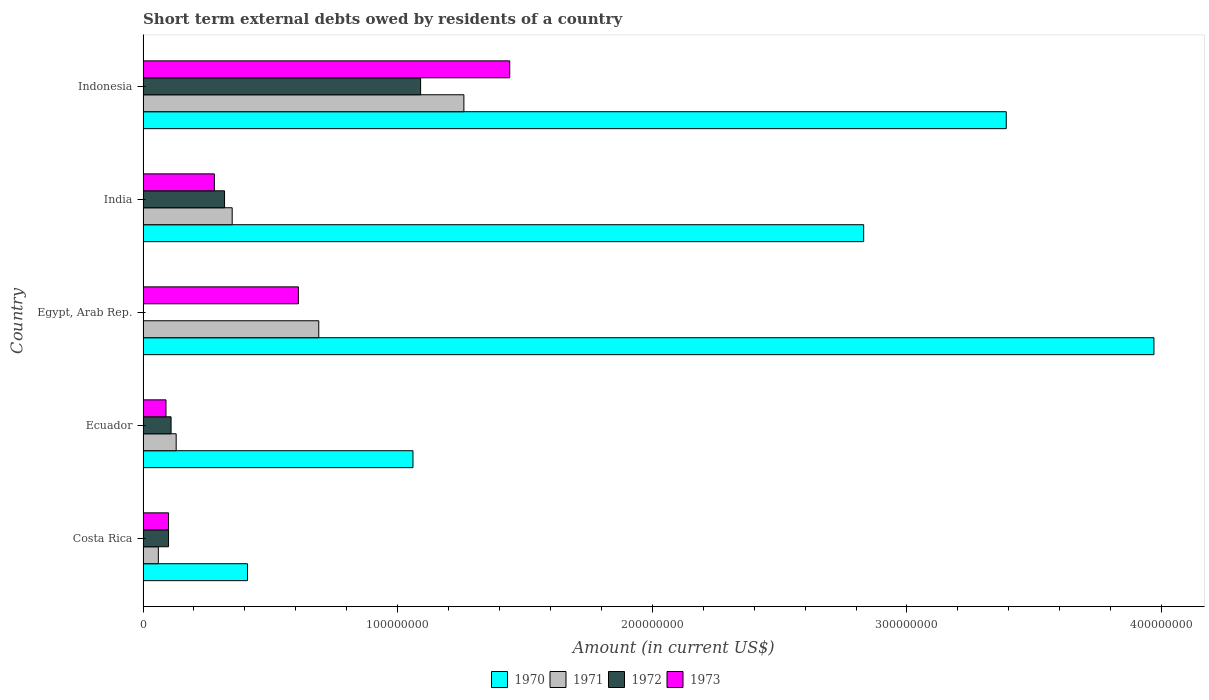How many different coloured bars are there?
Ensure brevity in your answer.  4. How many groups of bars are there?
Your answer should be compact. 5. Are the number of bars per tick equal to the number of legend labels?
Your response must be concise. No. Are the number of bars on each tick of the Y-axis equal?
Your answer should be compact. No. How many bars are there on the 2nd tick from the top?
Make the answer very short. 4. How many bars are there on the 3rd tick from the bottom?
Your response must be concise. 3. What is the label of the 5th group of bars from the top?
Provide a short and direct response. Costa Rica. In how many cases, is the number of bars for a given country not equal to the number of legend labels?
Provide a short and direct response. 1. What is the amount of short-term external debts owed by residents in 1973 in Egypt, Arab Rep.?
Give a very brief answer. 6.10e+07. Across all countries, what is the maximum amount of short-term external debts owed by residents in 1970?
Give a very brief answer. 3.97e+08. Across all countries, what is the minimum amount of short-term external debts owed by residents in 1973?
Provide a succinct answer. 9.00e+06. In which country was the amount of short-term external debts owed by residents in 1972 maximum?
Give a very brief answer. Indonesia. What is the total amount of short-term external debts owed by residents in 1973 in the graph?
Keep it short and to the point. 2.52e+08. What is the difference between the amount of short-term external debts owed by residents in 1973 in Ecuador and that in Egypt, Arab Rep.?
Offer a terse response. -5.20e+07. What is the difference between the amount of short-term external debts owed by residents in 1973 in Egypt, Arab Rep. and the amount of short-term external debts owed by residents in 1970 in India?
Ensure brevity in your answer.  -2.22e+08. What is the average amount of short-term external debts owed by residents in 1970 per country?
Offer a terse response. 2.33e+08. What is the ratio of the amount of short-term external debts owed by residents in 1973 in Costa Rica to that in Ecuador?
Provide a succinct answer. 1.11. Is the difference between the amount of short-term external debts owed by residents in 1972 in Costa Rica and Ecuador greater than the difference between the amount of short-term external debts owed by residents in 1971 in Costa Rica and Ecuador?
Make the answer very short. Yes. What is the difference between the highest and the second highest amount of short-term external debts owed by residents in 1973?
Keep it short and to the point. 8.30e+07. What is the difference between the highest and the lowest amount of short-term external debts owed by residents in 1971?
Ensure brevity in your answer.  1.20e+08. How many bars are there?
Offer a terse response. 19. Does the graph contain grids?
Your answer should be compact. No. Where does the legend appear in the graph?
Your answer should be compact. Bottom center. How many legend labels are there?
Your response must be concise. 4. What is the title of the graph?
Provide a short and direct response. Short term external debts owed by residents of a country. What is the label or title of the X-axis?
Offer a very short reply. Amount (in current US$). What is the label or title of the Y-axis?
Your answer should be very brief. Country. What is the Amount (in current US$) in 1970 in Costa Rica?
Ensure brevity in your answer.  4.10e+07. What is the Amount (in current US$) in 1973 in Costa Rica?
Your response must be concise. 1.00e+07. What is the Amount (in current US$) of 1970 in Ecuador?
Ensure brevity in your answer.  1.06e+08. What is the Amount (in current US$) of 1971 in Ecuador?
Offer a terse response. 1.30e+07. What is the Amount (in current US$) in 1972 in Ecuador?
Keep it short and to the point. 1.10e+07. What is the Amount (in current US$) of 1973 in Ecuador?
Provide a succinct answer. 9.00e+06. What is the Amount (in current US$) in 1970 in Egypt, Arab Rep.?
Offer a terse response. 3.97e+08. What is the Amount (in current US$) of 1971 in Egypt, Arab Rep.?
Your answer should be very brief. 6.90e+07. What is the Amount (in current US$) of 1973 in Egypt, Arab Rep.?
Offer a very short reply. 6.10e+07. What is the Amount (in current US$) of 1970 in India?
Your answer should be very brief. 2.83e+08. What is the Amount (in current US$) in 1971 in India?
Your answer should be very brief. 3.50e+07. What is the Amount (in current US$) of 1972 in India?
Offer a very short reply. 3.20e+07. What is the Amount (in current US$) in 1973 in India?
Provide a short and direct response. 2.80e+07. What is the Amount (in current US$) in 1970 in Indonesia?
Your answer should be compact. 3.39e+08. What is the Amount (in current US$) in 1971 in Indonesia?
Your response must be concise. 1.26e+08. What is the Amount (in current US$) of 1972 in Indonesia?
Provide a short and direct response. 1.09e+08. What is the Amount (in current US$) of 1973 in Indonesia?
Give a very brief answer. 1.44e+08. Across all countries, what is the maximum Amount (in current US$) of 1970?
Your response must be concise. 3.97e+08. Across all countries, what is the maximum Amount (in current US$) of 1971?
Make the answer very short. 1.26e+08. Across all countries, what is the maximum Amount (in current US$) of 1972?
Keep it short and to the point. 1.09e+08. Across all countries, what is the maximum Amount (in current US$) of 1973?
Your response must be concise. 1.44e+08. Across all countries, what is the minimum Amount (in current US$) in 1970?
Your answer should be very brief. 4.10e+07. Across all countries, what is the minimum Amount (in current US$) of 1973?
Keep it short and to the point. 9.00e+06. What is the total Amount (in current US$) of 1970 in the graph?
Your response must be concise. 1.17e+09. What is the total Amount (in current US$) of 1971 in the graph?
Your answer should be compact. 2.49e+08. What is the total Amount (in current US$) of 1972 in the graph?
Keep it short and to the point. 1.62e+08. What is the total Amount (in current US$) of 1973 in the graph?
Ensure brevity in your answer.  2.52e+08. What is the difference between the Amount (in current US$) in 1970 in Costa Rica and that in Ecuador?
Your response must be concise. -6.50e+07. What is the difference between the Amount (in current US$) of 1971 in Costa Rica and that in Ecuador?
Make the answer very short. -7.00e+06. What is the difference between the Amount (in current US$) in 1970 in Costa Rica and that in Egypt, Arab Rep.?
Keep it short and to the point. -3.56e+08. What is the difference between the Amount (in current US$) in 1971 in Costa Rica and that in Egypt, Arab Rep.?
Offer a very short reply. -6.30e+07. What is the difference between the Amount (in current US$) of 1973 in Costa Rica and that in Egypt, Arab Rep.?
Give a very brief answer. -5.10e+07. What is the difference between the Amount (in current US$) of 1970 in Costa Rica and that in India?
Ensure brevity in your answer.  -2.42e+08. What is the difference between the Amount (in current US$) of 1971 in Costa Rica and that in India?
Offer a terse response. -2.90e+07. What is the difference between the Amount (in current US$) in 1972 in Costa Rica and that in India?
Provide a short and direct response. -2.20e+07. What is the difference between the Amount (in current US$) of 1973 in Costa Rica and that in India?
Ensure brevity in your answer.  -1.80e+07. What is the difference between the Amount (in current US$) in 1970 in Costa Rica and that in Indonesia?
Offer a very short reply. -2.98e+08. What is the difference between the Amount (in current US$) of 1971 in Costa Rica and that in Indonesia?
Provide a succinct answer. -1.20e+08. What is the difference between the Amount (in current US$) of 1972 in Costa Rica and that in Indonesia?
Provide a short and direct response. -9.90e+07. What is the difference between the Amount (in current US$) of 1973 in Costa Rica and that in Indonesia?
Your answer should be very brief. -1.34e+08. What is the difference between the Amount (in current US$) in 1970 in Ecuador and that in Egypt, Arab Rep.?
Provide a succinct answer. -2.91e+08. What is the difference between the Amount (in current US$) of 1971 in Ecuador and that in Egypt, Arab Rep.?
Provide a short and direct response. -5.60e+07. What is the difference between the Amount (in current US$) in 1973 in Ecuador and that in Egypt, Arab Rep.?
Your response must be concise. -5.20e+07. What is the difference between the Amount (in current US$) of 1970 in Ecuador and that in India?
Provide a succinct answer. -1.77e+08. What is the difference between the Amount (in current US$) in 1971 in Ecuador and that in India?
Provide a succinct answer. -2.20e+07. What is the difference between the Amount (in current US$) in 1972 in Ecuador and that in India?
Provide a short and direct response. -2.10e+07. What is the difference between the Amount (in current US$) of 1973 in Ecuador and that in India?
Provide a succinct answer. -1.90e+07. What is the difference between the Amount (in current US$) of 1970 in Ecuador and that in Indonesia?
Keep it short and to the point. -2.33e+08. What is the difference between the Amount (in current US$) in 1971 in Ecuador and that in Indonesia?
Your answer should be very brief. -1.13e+08. What is the difference between the Amount (in current US$) of 1972 in Ecuador and that in Indonesia?
Offer a terse response. -9.80e+07. What is the difference between the Amount (in current US$) in 1973 in Ecuador and that in Indonesia?
Ensure brevity in your answer.  -1.35e+08. What is the difference between the Amount (in current US$) of 1970 in Egypt, Arab Rep. and that in India?
Ensure brevity in your answer.  1.14e+08. What is the difference between the Amount (in current US$) in 1971 in Egypt, Arab Rep. and that in India?
Make the answer very short. 3.40e+07. What is the difference between the Amount (in current US$) of 1973 in Egypt, Arab Rep. and that in India?
Your answer should be very brief. 3.30e+07. What is the difference between the Amount (in current US$) of 1970 in Egypt, Arab Rep. and that in Indonesia?
Your response must be concise. 5.80e+07. What is the difference between the Amount (in current US$) in 1971 in Egypt, Arab Rep. and that in Indonesia?
Your answer should be compact. -5.70e+07. What is the difference between the Amount (in current US$) in 1973 in Egypt, Arab Rep. and that in Indonesia?
Make the answer very short. -8.30e+07. What is the difference between the Amount (in current US$) in 1970 in India and that in Indonesia?
Your answer should be very brief. -5.60e+07. What is the difference between the Amount (in current US$) in 1971 in India and that in Indonesia?
Ensure brevity in your answer.  -9.10e+07. What is the difference between the Amount (in current US$) in 1972 in India and that in Indonesia?
Offer a terse response. -7.70e+07. What is the difference between the Amount (in current US$) in 1973 in India and that in Indonesia?
Provide a succinct answer. -1.16e+08. What is the difference between the Amount (in current US$) in 1970 in Costa Rica and the Amount (in current US$) in 1971 in Ecuador?
Keep it short and to the point. 2.80e+07. What is the difference between the Amount (in current US$) of 1970 in Costa Rica and the Amount (in current US$) of 1972 in Ecuador?
Your answer should be very brief. 3.00e+07. What is the difference between the Amount (in current US$) of 1970 in Costa Rica and the Amount (in current US$) of 1973 in Ecuador?
Your answer should be very brief. 3.20e+07. What is the difference between the Amount (in current US$) of 1971 in Costa Rica and the Amount (in current US$) of 1972 in Ecuador?
Your answer should be very brief. -5.00e+06. What is the difference between the Amount (in current US$) in 1970 in Costa Rica and the Amount (in current US$) in 1971 in Egypt, Arab Rep.?
Your response must be concise. -2.80e+07. What is the difference between the Amount (in current US$) of 1970 in Costa Rica and the Amount (in current US$) of 1973 in Egypt, Arab Rep.?
Keep it short and to the point. -2.00e+07. What is the difference between the Amount (in current US$) in 1971 in Costa Rica and the Amount (in current US$) in 1973 in Egypt, Arab Rep.?
Offer a very short reply. -5.50e+07. What is the difference between the Amount (in current US$) of 1972 in Costa Rica and the Amount (in current US$) of 1973 in Egypt, Arab Rep.?
Offer a very short reply. -5.10e+07. What is the difference between the Amount (in current US$) of 1970 in Costa Rica and the Amount (in current US$) of 1971 in India?
Your answer should be compact. 6.00e+06. What is the difference between the Amount (in current US$) in 1970 in Costa Rica and the Amount (in current US$) in 1972 in India?
Give a very brief answer. 9.00e+06. What is the difference between the Amount (in current US$) in 1970 in Costa Rica and the Amount (in current US$) in 1973 in India?
Make the answer very short. 1.30e+07. What is the difference between the Amount (in current US$) in 1971 in Costa Rica and the Amount (in current US$) in 1972 in India?
Your answer should be very brief. -2.60e+07. What is the difference between the Amount (in current US$) in 1971 in Costa Rica and the Amount (in current US$) in 1973 in India?
Offer a very short reply. -2.20e+07. What is the difference between the Amount (in current US$) of 1972 in Costa Rica and the Amount (in current US$) of 1973 in India?
Provide a short and direct response. -1.80e+07. What is the difference between the Amount (in current US$) in 1970 in Costa Rica and the Amount (in current US$) in 1971 in Indonesia?
Ensure brevity in your answer.  -8.50e+07. What is the difference between the Amount (in current US$) in 1970 in Costa Rica and the Amount (in current US$) in 1972 in Indonesia?
Make the answer very short. -6.80e+07. What is the difference between the Amount (in current US$) in 1970 in Costa Rica and the Amount (in current US$) in 1973 in Indonesia?
Provide a succinct answer. -1.03e+08. What is the difference between the Amount (in current US$) of 1971 in Costa Rica and the Amount (in current US$) of 1972 in Indonesia?
Your answer should be very brief. -1.03e+08. What is the difference between the Amount (in current US$) in 1971 in Costa Rica and the Amount (in current US$) in 1973 in Indonesia?
Your answer should be compact. -1.38e+08. What is the difference between the Amount (in current US$) of 1972 in Costa Rica and the Amount (in current US$) of 1973 in Indonesia?
Make the answer very short. -1.34e+08. What is the difference between the Amount (in current US$) of 1970 in Ecuador and the Amount (in current US$) of 1971 in Egypt, Arab Rep.?
Your answer should be very brief. 3.70e+07. What is the difference between the Amount (in current US$) in 1970 in Ecuador and the Amount (in current US$) in 1973 in Egypt, Arab Rep.?
Ensure brevity in your answer.  4.50e+07. What is the difference between the Amount (in current US$) in 1971 in Ecuador and the Amount (in current US$) in 1973 in Egypt, Arab Rep.?
Ensure brevity in your answer.  -4.80e+07. What is the difference between the Amount (in current US$) in 1972 in Ecuador and the Amount (in current US$) in 1973 in Egypt, Arab Rep.?
Make the answer very short. -5.00e+07. What is the difference between the Amount (in current US$) in 1970 in Ecuador and the Amount (in current US$) in 1971 in India?
Ensure brevity in your answer.  7.10e+07. What is the difference between the Amount (in current US$) in 1970 in Ecuador and the Amount (in current US$) in 1972 in India?
Your answer should be compact. 7.40e+07. What is the difference between the Amount (in current US$) in 1970 in Ecuador and the Amount (in current US$) in 1973 in India?
Keep it short and to the point. 7.80e+07. What is the difference between the Amount (in current US$) of 1971 in Ecuador and the Amount (in current US$) of 1972 in India?
Offer a very short reply. -1.90e+07. What is the difference between the Amount (in current US$) in 1971 in Ecuador and the Amount (in current US$) in 1973 in India?
Ensure brevity in your answer.  -1.50e+07. What is the difference between the Amount (in current US$) in 1972 in Ecuador and the Amount (in current US$) in 1973 in India?
Offer a terse response. -1.70e+07. What is the difference between the Amount (in current US$) of 1970 in Ecuador and the Amount (in current US$) of 1971 in Indonesia?
Your answer should be compact. -2.00e+07. What is the difference between the Amount (in current US$) in 1970 in Ecuador and the Amount (in current US$) in 1973 in Indonesia?
Ensure brevity in your answer.  -3.80e+07. What is the difference between the Amount (in current US$) of 1971 in Ecuador and the Amount (in current US$) of 1972 in Indonesia?
Provide a succinct answer. -9.60e+07. What is the difference between the Amount (in current US$) of 1971 in Ecuador and the Amount (in current US$) of 1973 in Indonesia?
Your response must be concise. -1.31e+08. What is the difference between the Amount (in current US$) of 1972 in Ecuador and the Amount (in current US$) of 1973 in Indonesia?
Give a very brief answer. -1.33e+08. What is the difference between the Amount (in current US$) of 1970 in Egypt, Arab Rep. and the Amount (in current US$) of 1971 in India?
Ensure brevity in your answer.  3.62e+08. What is the difference between the Amount (in current US$) of 1970 in Egypt, Arab Rep. and the Amount (in current US$) of 1972 in India?
Offer a very short reply. 3.65e+08. What is the difference between the Amount (in current US$) in 1970 in Egypt, Arab Rep. and the Amount (in current US$) in 1973 in India?
Offer a very short reply. 3.69e+08. What is the difference between the Amount (in current US$) in 1971 in Egypt, Arab Rep. and the Amount (in current US$) in 1972 in India?
Your response must be concise. 3.70e+07. What is the difference between the Amount (in current US$) of 1971 in Egypt, Arab Rep. and the Amount (in current US$) of 1973 in India?
Provide a succinct answer. 4.10e+07. What is the difference between the Amount (in current US$) in 1970 in Egypt, Arab Rep. and the Amount (in current US$) in 1971 in Indonesia?
Offer a very short reply. 2.71e+08. What is the difference between the Amount (in current US$) of 1970 in Egypt, Arab Rep. and the Amount (in current US$) of 1972 in Indonesia?
Ensure brevity in your answer.  2.88e+08. What is the difference between the Amount (in current US$) of 1970 in Egypt, Arab Rep. and the Amount (in current US$) of 1973 in Indonesia?
Make the answer very short. 2.53e+08. What is the difference between the Amount (in current US$) of 1971 in Egypt, Arab Rep. and the Amount (in current US$) of 1972 in Indonesia?
Ensure brevity in your answer.  -4.00e+07. What is the difference between the Amount (in current US$) in 1971 in Egypt, Arab Rep. and the Amount (in current US$) in 1973 in Indonesia?
Keep it short and to the point. -7.50e+07. What is the difference between the Amount (in current US$) of 1970 in India and the Amount (in current US$) of 1971 in Indonesia?
Your answer should be compact. 1.57e+08. What is the difference between the Amount (in current US$) of 1970 in India and the Amount (in current US$) of 1972 in Indonesia?
Offer a very short reply. 1.74e+08. What is the difference between the Amount (in current US$) of 1970 in India and the Amount (in current US$) of 1973 in Indonesia?
Offer a terse response. 1.39e+08. What is the difference between the Amount (in current US$) of 1971 in India and the Amount (in current US$) of 1972 in Indonesia?
Your answer should be very brief. -7.40e+07. What is the difference between the Amount (in current US$) in 1971 in India and the Amount (in current US$) in 1973 in Indonesia?
Your answer should be very brief. -1.09e+08. What is the difference between the Amount (in current US$) of 1972 in India and the Amount (in current US$) of 1973 in Indonesia?
Offer a very short reply. -1.12e+08. What is the average Amount (in current US$) of 1970 per country?
Provide a succinct answer. 2.33e+08. What is the average Amount (in current US$) of 1971 per country?
Offer a very short reply. 4.98e+07. What is the average Amount (in current US$) in 1972 per country?
Make the answer very short. 3.24e+07. What is the average Amount (in current US$) in 1973 per country?
Your answer should be very brief. 5.04e+07. What is the difference between the Amount (in current US$) in 1970 and Amount (in current US$) in 1971 in Costa Rica?
Provide a succinct answer. 3.50e+07. What is the difference between the Amount (in current US$) of 1970 and Amount (in current US$) of 1972 in Costa Rica?
Give a very brief answer. 3.10e+07. What is the difference between the Amount (in current US$) of 1970 and Amount (in current US$) of 1973 in Costa Rica?
Keep it short and to the point. 3.10e+07. What is the difference between the Amount (in current US$) in 1972 and Amount (in current US$) in 1973 in Costa Rica?
Your answer should be compact. 0. What is the difference between the Amount (in current US$) of 1970 and Amount (in current US$) of 1971 in Ecuador?
Your answer should be compact. 9.30e+07. What is the difference between the Amount (in current US$) in 1970 and Amount (in current US$) in 1972 in Ecuador?
Offer a terse response. 9.50e+07. What is the difference between the Amount (in current US$) of 1970 and Amount (in current US$) of 1973 in Ecuador?
Give a very brief answer. 9.70e+07. What is the difference between the Amount (in current US$) of 1971 and Amount (in current US$) of 1973 in Ecuador?
Ensure brevity in your answer.  4.00e+06. What is the difference between the Amount (in current US$) of 1972 and Amount (in current US$) of 1973 in Ecuador?
Make the answer very short. 2.00e+06. What is the difference between the Amount (in current US$) in 1970 and Amount (in current US$) in 1971 in Egypt, Arab Rep.?
Ensure brevity in your answer.  3.28e+08. What is the difference between the Amount (in current US$) in 1970 and Amount (in current US$) in 1973 in Egypt, Arab Rep.?
Make the answer very short. 3.36e+08. What is the difference between the Amount (in current US$) of 1971 and Amount (in current US$) of 1973 in Egypt, Arab Rep.?
Offer a terse response. 8.00e+06. What is the difference between the Amount (in current US$) of 1970 and Amount (in current US$) of 1971 in India?
Your answer should be compact. 2.48e+08. What is the difference between the Amount (in current US$) in 1970 and Amount (in current US$) in 1972 in India?
Offer a terse response. 2.51e+08. What is the difference between the Amount (in current US$) of 1970 and Amount (in current US$) of 1973 in India?
Your response must be concise. 2.55e+08. What is the difference between the Amount (in current US$) in 1971 and Amount (in current US$) in 1972 in India?
Provide a succinct answer. 3.00e+06. What is the difference between the Amount (in current US$) in 1970 and Amount (in current US$) in 1971 in Indonesia?
Provide a succinct answer. 2.13e+08. What is the difference between the Amount (in current US$) of 1970 and Amount (in current US$) of 1972 in Indonesia?
Offer a terse response. 2.30e+08. What is the difference between the Amount (in current US$) of 1970 and Amount (in current US$) of 1973 in Indonesia?
Make the answer very short. 1.95e+08. What is the difference between the Amount (in current US$) of 1971 and Amount (in current US$) of 1972 in Indonesia?
Your response must be concise. 1.70e+07. What is the difference between the Amount (in current US$) of 1971 and Amount (in current US$) of 1973 in Indonesia?
Give a very brief answer. -1.80e+07. What is the difference between the Amount (in current US$) in 1972 and Amount (in current US$) in 1973 in Indonesia?
Your answer should be compact. -3.50e+07. What is the ratio of the Amount (in current US$) in 1970 in Costa Rica to that in Ecuador?
Provide a short and direct response. 0.39. What is the ratio of the Amount (in current US$) of 1971 in Costa Rica to that in Ecuador?
Your response must be concise. 0.46. What is the ratio of the Amount (in current US$) of 1970 in Costa Rica to that in Egypt, Arab Rep.?
Make the answer very short. 0.1. What is the ratio of the Amount (in current US$) of 1971 in Costa Rica to that in Egypt, Arab Rep.?
Provide a short and direct response. 0.09. What is the ratio of the Amount (in current US$) in 1973 in Costa Rica to that in Egypt, Arab Rep.?
Ensure brevity in your answer.  0.16. What is the ratio of the Amount (in current US$) of 1970 in Costa Rica to that in India?
Ensure brevity in your answer.  0.14. What is the ratio of the Amount (in current US$) of 1971 in Costa Rica to that in India?
Give a very brief answer. 0.17. What is the ratio of the Amount (in current US$) of 1972 in Costa Rica to that in India?
Offer a very short reply. 0.31. What is the ratio of the Amount (in current US$) in 1973 in Costa Rica to that in India?
Provide a succinct answer. 0.36. What is the ratio of the Amount (in current US$) of 1970 in Costa Rica to that in Indonesia?
Ensure brevity in your answer.  0.12. What is the ratio of the Amount (in current US$) of 1971 in Costa Rica to that in Indonesia?
Offer a very short reply. 0.05. What is the ratio of the Amount (in current US$) in 1972 in Costa Rica to that in Indonesia?
Provide a succinct answer. 0.09. What is the ratio of the Amount (in current US$) of 1973 in Costa Rica to that in Indonesia?
Your response must be concise. 0.07. What is the ratio of the Amount (in current US$) of 1970 in Ecuador to that in Egypt, Arab Rep.?
Offer a terse response. 0.27. What is the ratio of the Amount (in current US$) in 1971 in Ecuador to that in Egypt, Arab Rep.?
Offer a terse response. 0.19. What is the ratio of the Amount (in current US$) of 1973 in Ecuador to that in Egypt, Arab Rep.?
Offer a very short reply. 0.15. What is the ratio of the Amount (in current US$) in 1970 in Ecuador to that in India?
Offer a very short reply. 0.37. What is the ratio of the Amount (in current US$) in 1971 in Ecuador to that in India?
Make the answer very short. 0.37. What is the ratio of the Amount (in current US$) of 1972 in Ecuador to that in India?
Offer a terse response. 0.34. What is the ratio of the Amount (in current US$) of 1973 in Ecuador to that in India?
Offer a terse response. 0.32. What is the ratio of the Amount (in current US$) in 1970 in Ecuador to that in Indonesia?
Your response must be concise. 0.31. What is the ratio of the Amount (in current US$) of 1971 in Ecuador to that in Indonesia?
Your answer should be compact. 0.1. What is the ratio of the Amount (in current US$) of 1972 in Ecuador to that in Indonesia?
Offer a very short reply. 0.1. What is the ratio of the Amount (in current US$) in 1973 in Ecuador to that in Indonesia?
Keep it short and to the point. 0.06. What is the ratio of the Amount (in current US$) of 1970 in Egypt, Arab Rep. to that in India?
Make the answer very short. 1.4. What is the ratio of the Amount (in current US$) in 1971 in Egypt, Arab Rep. to that in India?
Your response must be concise. 1.97. What is the ratio of the Amount (in current US$) of 1973 in Egypt, Arab Rep. to that in India?
Offer a very short reply. 2.18. What is the ratio of the Amount (in current US$) of 1970 in Egypt, Arab Rep. to that in Indonesia?
Provide a succinct answer. 1.17. What is the ratio of the Amount (in current US$) of 1971 in Egypt, Arab Rep. to that in Indonesia?
Provide a short and direct response. 0.55. What is the ratio of the Amount (in current US$) in 1973 in Egypt, Arab Rep. to that in Indonesia?
Offer a very short reply. 0.42. What is the ratio of the Amount (in current US$) of 1970 in India to that in Indonesia?
Give a very brief answer. 0.83. What is the ratio of the Amount (in current US$) of 1971 in India to that in Indonesia?
Make the answer very short. 0.28. What is the ratio of the Amount (in current US$) of 1972 in India to that in Indonesia?
Keep it short and to the point. 0.29. What is the ratio of the Amount (in current US$) of 1973 in India to that in Indonesia?
Make the answer very short. 0.19. What is the difference between the highest and the second highest Amount (in current US$) in 1970?
Provide a succinct answer. 5.80e+07. What is the difference between the highest and the second highest Amount (in current US$) of 1971?
Offer a very short reply. 5.70e+07. What is the difference between the highest and the second highest Amount (in current US$) of 1972?
Your response must be concise. 7.70e+07. What is the difference between the highest and the second highest Amount (in current US$) of 1973?
Make the answer very short. 8.30e+07. What is the difference between the highest and the lowest Amount (in current US$) of 1970?
Provide a succinct answer. 3.56e+08. What is the difference between the highest and the lowest Amount (in current US$) in 1971?
Offer a terse response. 1.20e+08. What is the difference between the highest and the lowest Amount (in current US$) in 1972?
Your answer should be very brief. 1.09e+08. What is the difference between the highest and the lowest Amount (in current US$) of 1973?
Offer a very short reply. 1.35e+08. 